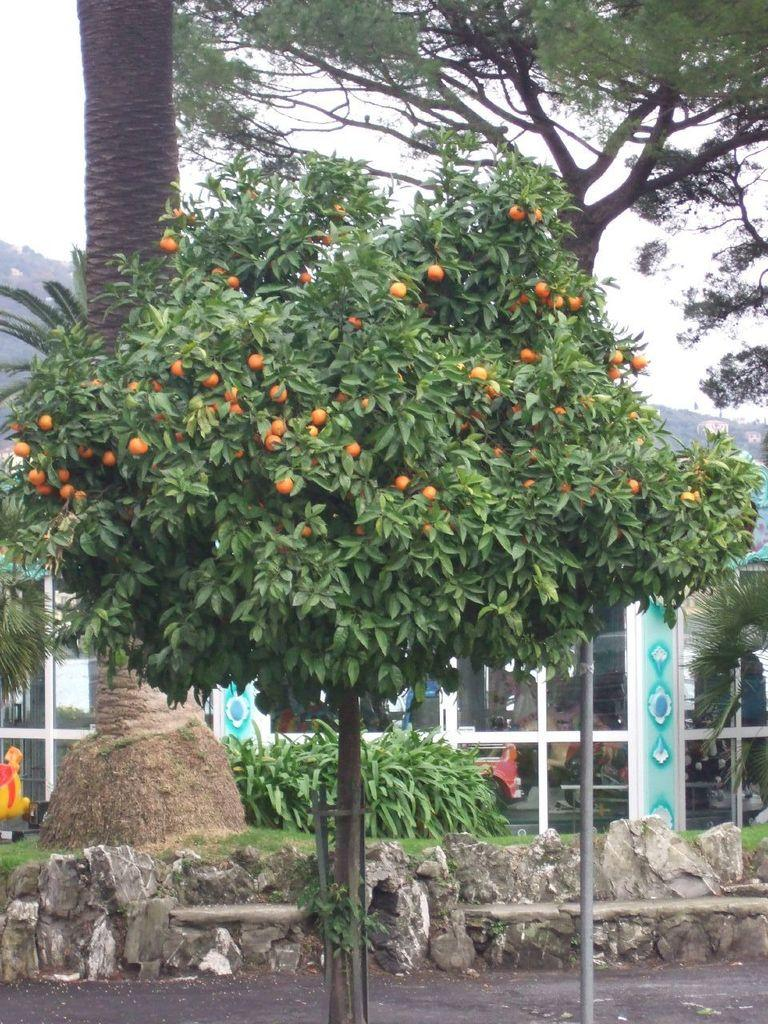What type of tree is present in the image? There is a tree with oranges in the image. Can you describe the background of the image? There are other trees and objects in the background of the image. What advice does the father give to the child at the edge of the image? There is no father or child present in the image, and therefore no advice can be given. 